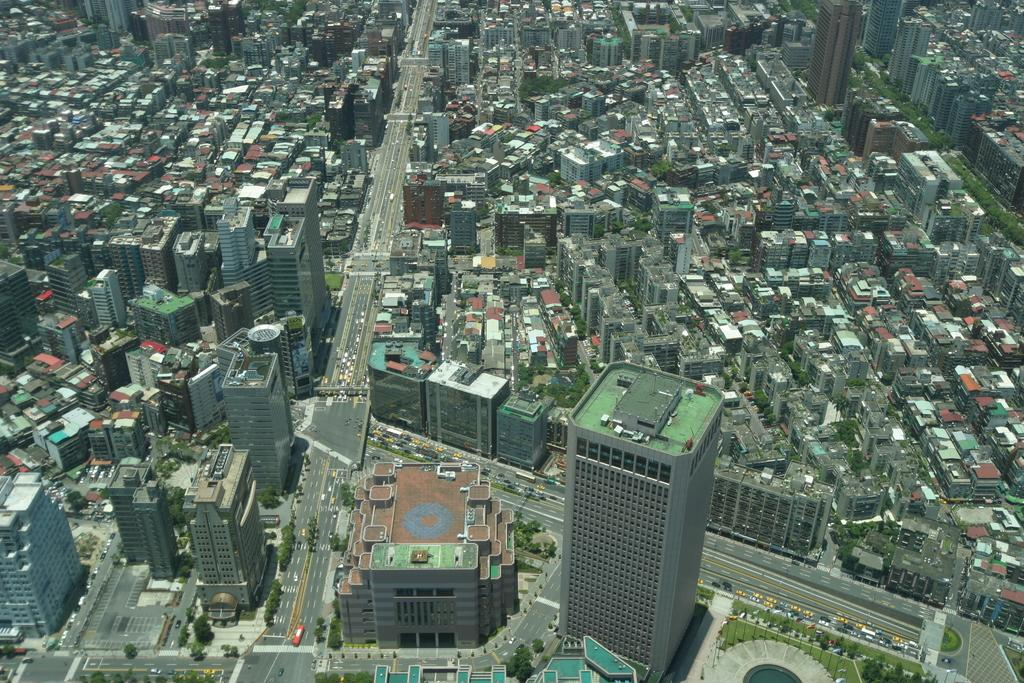What perspective is used in the image? The image is a top view. What type of natural elements can be seen in the image? There are trees in the image. What type of man-made structures are present in the image? There are buildings in the image. What connects the buildings in the image? There is a road between the buildings in the image. What word is written on the mine in the image? There is no mine present in the image, so it is not possible to answer that question. 